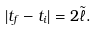<formula> <loc_0><loc_0><loc_500><loc_500>| t _ { f } - t _ { i } | = 2 \tilde { \ell } .</formula> 